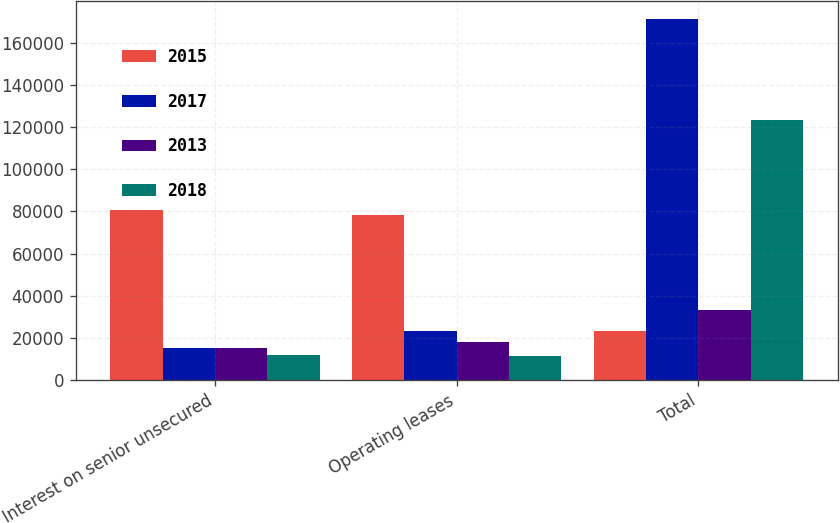<chart> <loc_0><loc_0><loc_500><loc_500><stacked_bar_chart><ecel><fcel>Interest on senior unsecured<fcel>Operating leases<fcel>Total<nl><fcel>2015<fcel>80721<fcel>78112<fcel>23243<nl><fcel>2017<fcel>15205<fcel>23243<fcel>171229<nl><fcel>2013<fcel>15205<fcel>18135<fcel>33340<nl><fcel>2018<fcel>11768<fcel>11456<fcel>123224<nl></chart> 